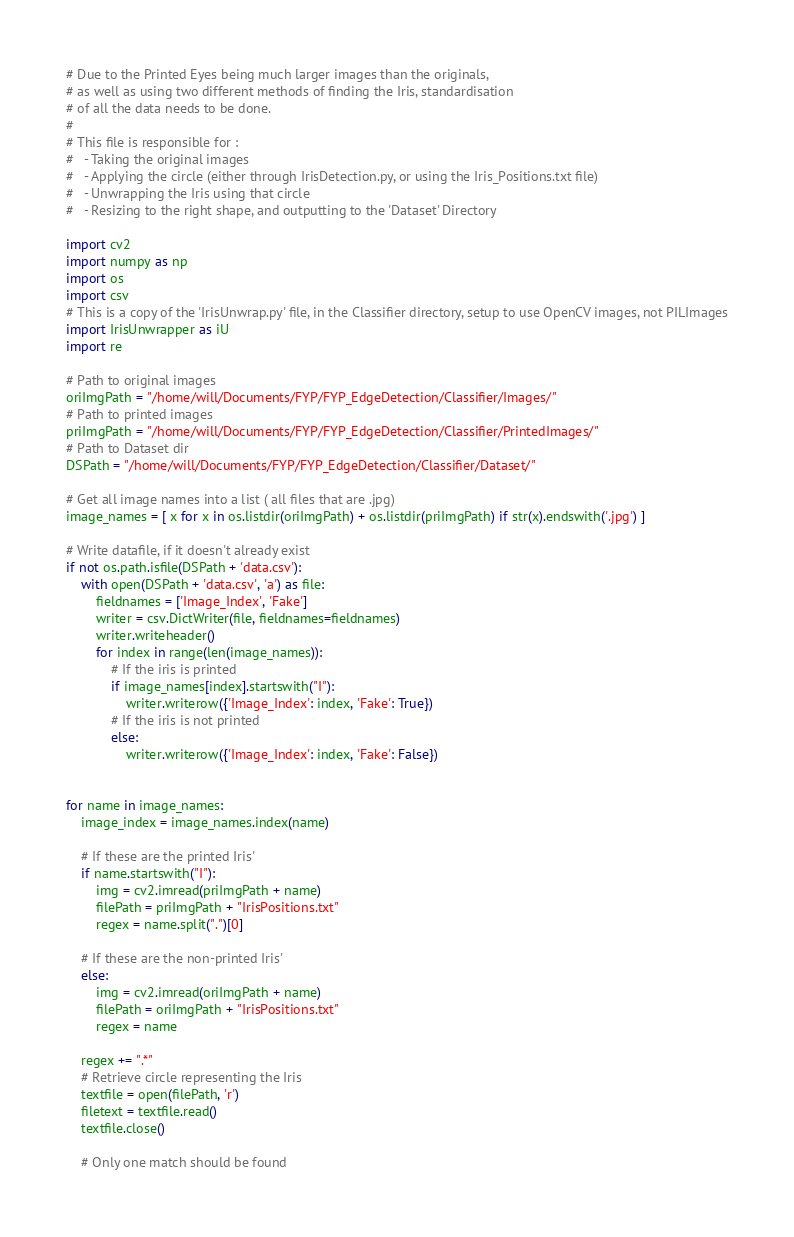<code> <loc_0><loc_0><loc_500><loc_500><_Python_># Due to the Printed Eyes being much larger images than the originals,
# as well as using two different methods of finding the Iris, standardisation
# of all the data needs to be done.
#
# This file is responsible for :
#   - Taking the original images
#   - Applying the circle (either through IrisDetection.py, or using the Iris_Positions.txt file)
#   - Unwrapping the Iris using that circle
#   - Resizing to the right shape, and outputting to the 'Dataset' Directory

import cv2
import numpy as np
import os
import csv
# This is a copy of the 'IrisUnwrap.py' file, in the Classifier directory, setup to use OpenCV images, not PILImages
import IrisUnwrapper as iU
import re

# Path to original images
oriImgPath = "/home/will/Documents/FYP/FYP_EdgeDetection/Classifier/Images/"
# Path to printed images
priImgPath = "/home/will/Documents/FYP/FYP_EdgeDetection/Classifier/PrintedImages/"
# Path to Dataset dir
DSPath = "/home/will/Documents/FYP/FYP_EdgeDetection/Classifier/Dataset/"

# Get all image names into a list ( all files that are .jpg)
image_names = [ x for x in os.listdir(oriImgPath) + os.listdir(priImgPath) if str(x).endswith('.jpg') ]

# Write datafile, if it doesn't already exist
if not os.path.isfile(DSPath + 'data.csv'):
    with open(DSPath + 'data.csv', 'a') as file:
        fieldnames = ['Image_Index', 'Fake']
        writer = csv.DictWriter(file, fieldnames=fieldnames)
        writer.writeheader()
        for index in range(len(image_names)):
            # If the iris is printed
            if image_names[index].startswith("I"):
                writer.writerow({'Image_Index': index, 'Fake': True})
            # If the iris is not printed
            else:
                writer.writerow({'Image_Index': index, 'Fake': False})


for name in image_names:
    image_index = image_names.index(name)
    
    # If these are the printed Iris'
    if name.startswith("I"):
        img = cv2.imread(priImgPath + name)
        filePath = priImgPath + "IrisPositions.txt"
        regex = name.split(".")[0]

    # If these are the non-printed Iris'
    else:
        img = cv2.imread(oriImgPath + name)
        filePath = oriImgPath + "IrisPositions.txt"
        regex = name

    regex += ".*"
    # Retrieve circle representing the Iris
    textfile = open(filePath, 'r')
    filetext = textfile.read()
    textfile.close()

    # Only one match should be found</code> 